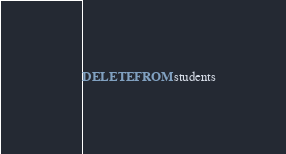<code> <loc_0><loc_0><loc_500><loc_500><_SQL_>DELETE FROM students
</code> 